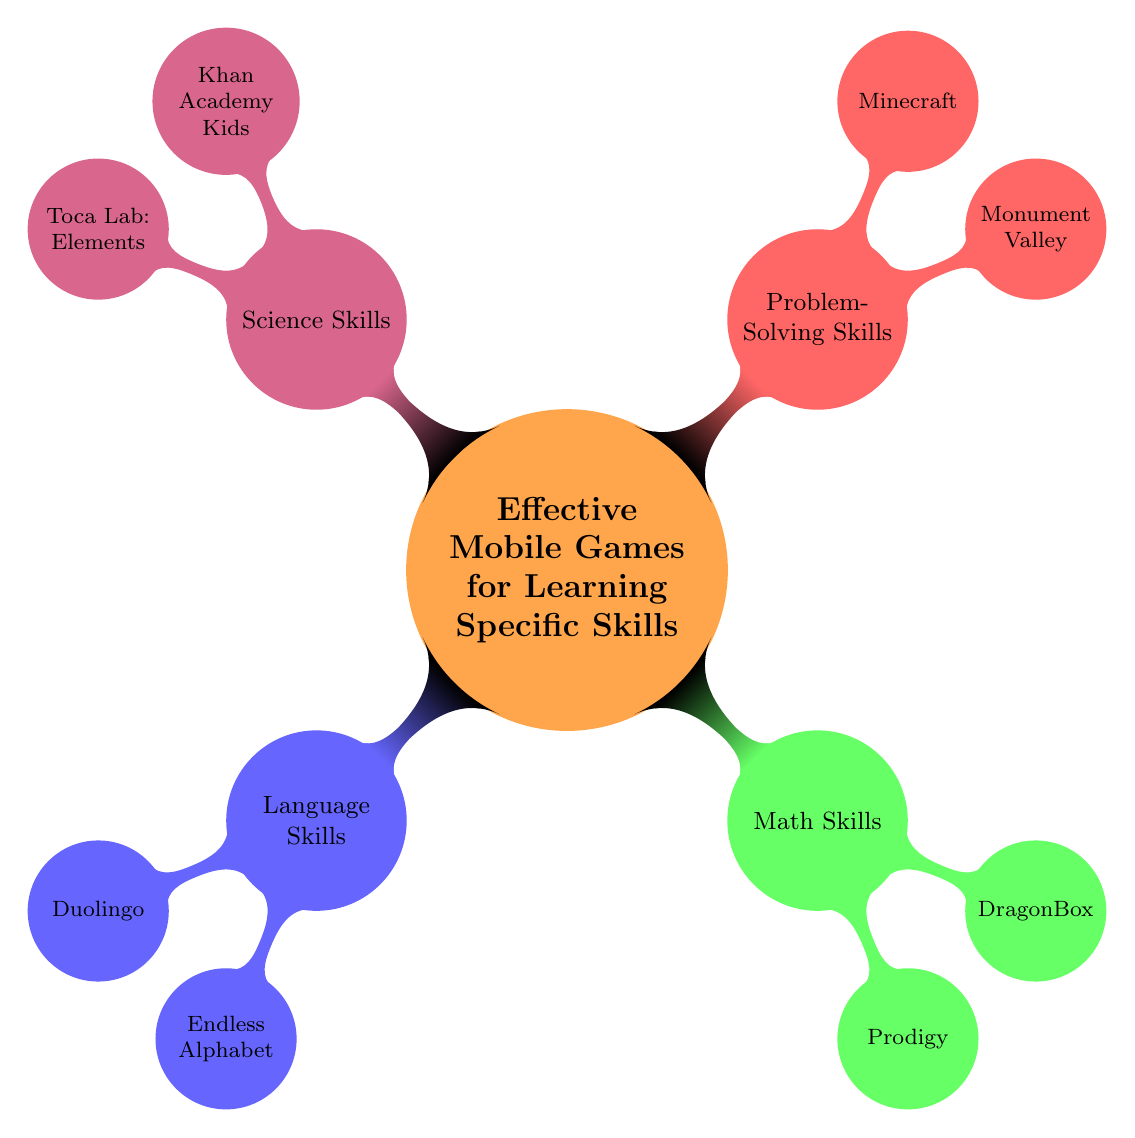What are the two games listed under Language Skills? According to the diagram, the Language Skills category contains two games: Duolingo and Endless Alphabet. This can be identified by tracing the branch labeled "Language Skills" which has those two sub-nodes.
Answer: Duolingo, Endless Alphabet How many skills categories are displayed in the diagram? The diagram has four main categories of skills displayed: Language Skills, Math Skills, Problem-Solving Skills, and Science Skills. By counting the top-level nodes, we find there are four.
Answer: 4 Which game is associated with Problem-Solving Skills? The Problem-Solving Skills category displays two games: Monument Valley and Minecraft. The question can be answered by identifying the sub-nodes under the Problem-Solving Skills node.
Answer: Monument Valley, Minecraft What is the primary focus of the game DragonBox? According to the diagram, DragonBox is identified as focusing on Math Fundamentals, which is stated directly next to the game under the Math Skills category.
Answer: Math Fundamentals Which skill type is associated with the game Toca Lab: Elements? Toca Lab: Elements is located under the Science Skills category in the diagram. By following the branch labeled Science Skills, we can find it.
Answer: Science Skills Which category has the game Prodigy? The game Prodigy is found under the Math Skills category. By observing the connections between the main categories and their sub-nodes, we can determine the category it belongs to.
Answer: Math Skills How many games are listed under each skill category? Language Skills has 2 games (Duolingo, Endless Alphabet), Math Skills has 2 games (Prodigy, DragonBox), Problem-Solving Skills has 2 games (Monument Valley, Minecraft), and Science Skills has 2 games (Khan Academy Kids, Toca Lab: Elements). Thus, each skill category consistently has the same number of games.
Answer: 2 games per category Which game is intended for general science education? The game aimed at general science education is Khan Academy Kids, which is explicitly labeled under the Science Skills category in the diagram.
Answer: Khan Academy Kids 